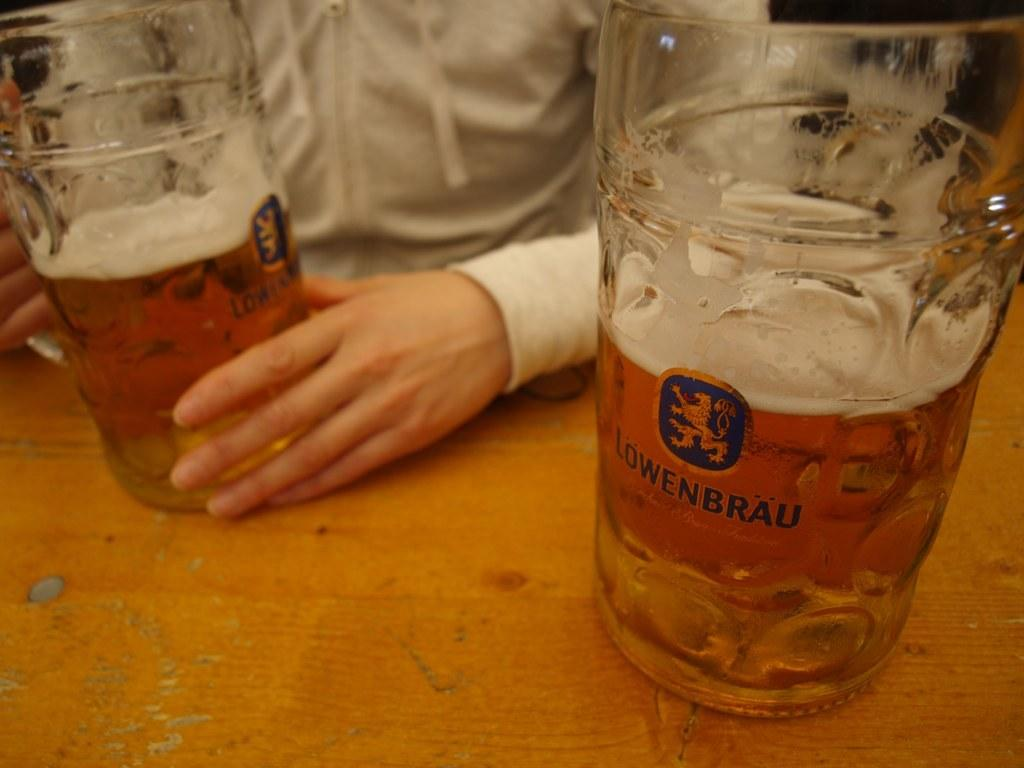<image>
Share a concise interpretation of the image provided. a large mug with lawenbrau beer in it is on a table 